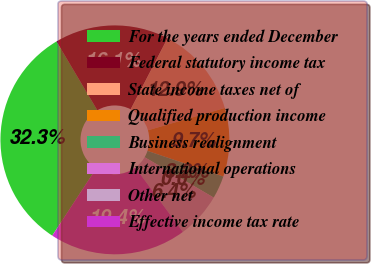Convert chart to OTSL. <chart><loc_0><loc_0><loc_500><loc_500><pie_chart><fcel>For the years ended December<fcel>Federal statutory income tax<fcel>State income taxes net of<fcel>Qualified production income<fcel>Business realignment<fcel>International operations<fcel>Other net<fcel>Effective income tax rate<nl><fcel>32.26%<fcel>16.13%<fcel>12.9%<fcel>9.68%<fcel>3.23%<fcel>0.0%<fcel>6.45%<fcel>19.35%<nl></chart> 